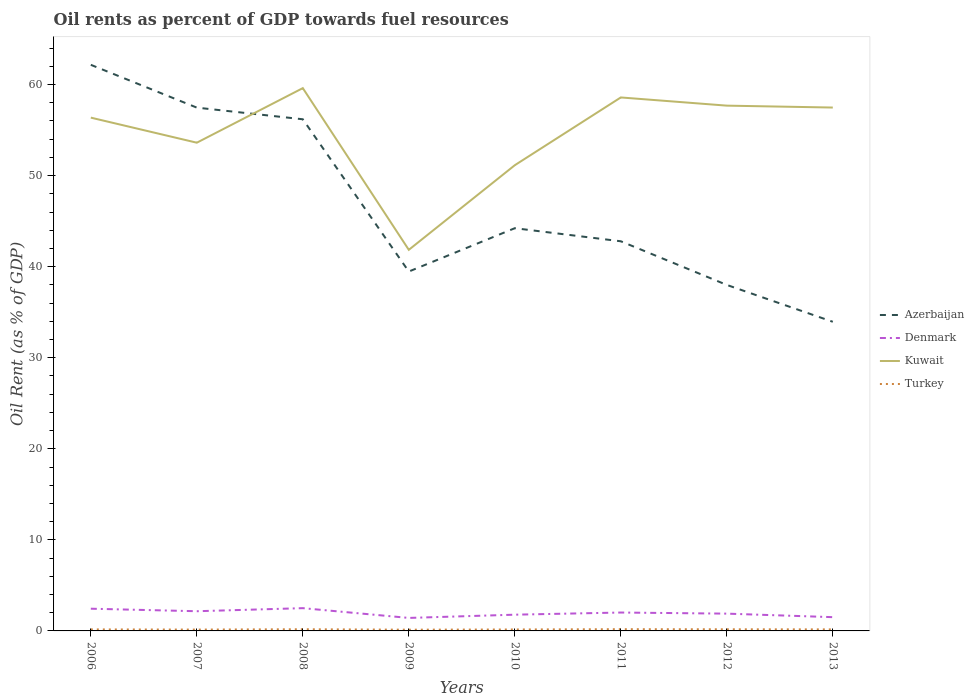Is the number of lines equal to the number of legend labels?
Provide a succinct answer. Yes. Across all years, what is the maximum oil rent in Denmark?
Keep it short and to the point. 1.43. In which year was the oil rent in Turkey maximum?
Offer a terse response. 2009. What is the total oil rent in Kuwait in the graph?
Your response must be concise. -5.99. What is the difference between the highest and the second highest oil rent in Kuwait?
Keep it short and to the point. 17.76. How many lines are there?
Give a very brief answer. 4. Are the values on the major ticks of Y-axis written in scientific E-notation?
Keep it short and to the point. No. What is the title of the graph?
Provide a succinct answer. Oil rents as percent of GDP towards fuel resources. Does "Sierra Leone" appear as one of the legend labels in the graph?
Offer a terse response. No. What is the label or title of the Y-axis?
Offer a terse response. Oil Rent (as % of GDP). What is the Oil Rent (as % of GDP) of Azerbaijan in 2006?
Ensure brevity in your answer.  62.17. What is the Oil Rent (as % of GDP) of Denmark in 2006?
Keep it short and to the point. 2.44. What is the Oil Rent (as % of GDP) of Kuwait in 2006?
Ensure brevity in your answer.  56.37. What is the Oil Rent (as % of GDP) of Turkey in 2006?
Keep it short and to the point. 0.17. What is the Oil Rent (as % of GDP) of Azerbaijan in 2007?
Give a very brief answer. 57.47. What is the Oil Rent (as % of GDP) in Denmark in 2007?
Offer a very short reply. 2.16. What is the Oil Rent (as % of GDP) in Kuwait in 2007?
Keep it short and to the point. 53.61. What is the Oil Rent (as % of GDP) in Turkey in 2007?
Provide a succinct answer. 0.15. What is the Oil Rent (as % of GDP) in Azerbaijan in 2008?
Provide a short and direct response. 56.19. What is the Oil Rent (as % of GDP) of Denmark in 2008?
Make the answer very short. 2.5. What is the Oil Rent (as % of GDP) in Kuwait in 2008?
Keep it short and to the point. 59.61. What is the Oil Rent (as % of GDP) in Turkey in 2008?
Offer a very short reply. 0.18. What is the Oil Rent (as % of GDP) of Azerbaijan in 2009?
Make the answer very short. 39.47. What is the Oil Rent (as % of GDP) of Denmark in 2009?
Your response must be concise. 1.43. What is the Oil Rent (as % of GDP) of Kuwait in 2009?
Ensure brevity in your answer.  41.85. What is the Oil Rent (as % of GDP) of Turkey in 2009?
Your response must be concise. 0.14. What is the Oil Rent (as % of GDP) of Azerbaijan in 2010?
Your answer should be compact. 44.22. What is the Oil Rent (as % of GDP) of Denmark in 2010?
Make the answer very short. 1.78. What is the Oil Rent (as % of GDP) in Kuwait in 2010?
Provide a succinct answer. 51.14. What is the Oil Rent (as % of GDP) of Turkey in 2010?
Make the answer very short. 0.16. What is the Oil Rent (as % of GDP) of Azerbaijan in 2011?
Provide a short and direct response. 42.79. What is the Oil Rent (as % of GDP) in Denmark in 2011?
Ensure brevity in your answer.  2.02. What is the Oil Rent (as % of GDP) of Kuwait in 2011?
Ensure brevity in your answer.  58.58. What is the Oil Rent (as % of GDP) of Turkey in 2011?
Your answer should be compact. 0.19. What is the Oil Rent (as % of GDP) in Azerbaijan in 2012?
Ensure brevity in your answer.  37.99. What is the Oil Rent (as % of GDP) in Denmark in 2012?
Your answer should be very brief. 1.9. What is the Oil Rent (as % of GDP) in Kuwait in 2012?
Your answer should be compact. 57.68. What is the Oil Rent (as % of GDP) of Turkey in 2012?
Your answer should be compact. 0.18. What is the Oil Rent (as % of GDP) in Azerbaijan in 2013?
Your answer should be compact. 33.95. What is the Oil Rent (as % of GDP) in Denmark in 2013?
Your answer should be very brief. 1.51. What is the Oil Rent (as % of GDP) in Kuwait in 2013?
Make the answer very short. 57.47. What is the Oil Rent (as % of GDP) in Turkey in 2013?
Your answer should be very brief. 0.17. Across all years, what is the maximum Oil Rent (as % of GDP) in Azerbaijan?
Offer a terse response. 62.17. Across all years, what is the maximum Oil Rent (as % of GDP) of Denmark?
Offer a terse response. 2.5. Across all years, what is the maximum Oil Rent (as % of GDP) of Kuwait?
Make the answer very short. 59.61. Across all years, what is the maximum Oil Rent (as % of GDP) of Turkey?
Make the answer very short. 0.19. Across all years, what is the minimum Oil Rent (as % of GDP) in Azerbaijan?
Provide a short and direct response. 33.95. Across all years, what is the minimum Oil Rent (as % of GDP) in Denmark?
Make the answer very short. 1.43. Across all years, what is the minimum Oil Rent (as % of GDP) of Kuwait?
Your answer should be very brief. 41.85. Across all years, what is the minimum Oil Rent (as % of GDP) of Turkey?
Give a very brief answer. 0.14. What is the total Oil Rent (as % of GDP) of Azerbaijan in the graph?
Keep it short and to the point. 374.24. What is the total Oil Rent (as % of GDP) of Denmark in the graph?
Provide a succinct answer. 15.74. What is the total Oil Rent (as % of GDP) of Kuwait in the graph?
Give a very brief answer. 436.31. What is the total Oil Rent (as % of GDP) of Turkey in the graph?
Keep it short and to the point. 1.33. What is the difference between the Oil Rent (as % of GDP) in Azerbaijan in 2006 and that in 2007?
Provide a succinct answer. 4.7. What is the difference between the Oil Rent (as % of GDP) in Denmark in 2006 and that in 2007?
Provide a succinct answer. 0.28. What is the difference between the Oil Rent (as % of GDP) in Kuwait in 2006 and that in 2007?
Your answer should be very brief. 2.75. What is the difference between the Oil Rent (as % of GDP) of Turkey in 2006 and that in 2007?
Your answer should be compact. 0.02. What is the difference between the Oil Rent (as % of GDP) in Azerbaijan in 2006 and that in 2008?
Ensure brevity in your answer.  5.98. What is the difference between the Oil Rent (as % of GDP) of Denmark in 2006 and that in 2008?
Your answer should be compact. -0.06. What is the difference between the Oil Rent (as % of GDP) in Kuwait in 2006 and that in 2008?
Provide a short and direct response. -3.24. What is the difference between the Oil Rent (as % of GDP) of Turkey in 2006 and that in 2008?
Keep it short and to the point. -0.02. What is the difference between the Oil Rent (as % of GDP) in Azerbaijan in 2006 and that in 2009?
Your answer should be compact. 22.7. What is the difference between the Oil Rent (as % of GDP) in Denmark in 2006 and that in 2009?
Provide a succinct answer. 1.01. What is the difference between the Oil Rent (as % of GDP) of Kuwait in 2006 and that in 2009?
Make the answer very short. 14.52. What is the difference between the Oil Rent (as % of GDP) of Turkey in 2006 and that in 2009?
Offer a terse response. 0.03. What is the difference between the Oil Rent (as % of GDP) of Azerbaijan in 2006 and that in 2010?
Provide a succinct answer. 17.94. What is the difference between the Oil Rent (as % of GDP) of Denmark in 2006 and that in 2010?
Provide a succinct answer. 0.66. What is the difference between the Oil Rent (as % of GDP) in Kuwait in 2006 and that in 2010?
Offer a very short reply. 5.22. What is the difference between the Oil Rent (as % of GDP) in Turkey in 2006 and that in 2010?
Your response must be concise. 0.01. What is the difference between the Oil Rent (as % of GDP) in Azerbaijan in 2006 and that in 2011?
Keep it short and to the point. 19.38. What is the difference between the Oil Rent (as % of GDP) in Denmark in 2006 and that in 2011?
Provide a succinct answer. 0.42. What is the difference between the Oil Rent (as % of GDP) of Kuwait in 2006 and that in 2011?
Provide a succinct answer. -2.22. What is the difference between the Oil Rent (as % of GDP) of Turkey in 2006 and that in 2011?
Provide a short and direct response. -0.02. What is the difference between the Oil Rent (as % of GDP) of Azerbaijan in 2006 and that in 2012?
Provide a succinct answer. 24.17. What is the difference between the Oil Rent (as % of GDP) of Denmark in 2006 and that in 2012?
Your answer should be compact. 0.54. What is the difference between the Oil Rent (as % of GDP) of Kuwait in 2006 and that in 2012?
Provide a short and direct response. -1.32. What is the difference between the Oil Rent (as % of GDP) of Turkey in 2006 and that in 2012?
Keep it short and to the point. -0.01. What is the difference between the Oil Rent (as % of GDP) in Azerbaijan in 2006 and that in 2013?
Ensure brevity in your answer.  28.22. What is the difference between the Oil Rent (as % of GDP) in Denmark in 2006 and that in 2013?
Offer a very short reply. 0.93. What is the difference between the Oil Rent (as % of GDP) of Kuwait in 2006 and that in 2013?
Your answer should be very brief. -1.11. What is the difference between the Oil Rent (as % of GDP) in Turkey in 2006 and that in 2013?
Keep it short and to the point. -0. What is the difference between the Oil Rent (as % of GDP) of Azerbaijan in 2007 and that in 2008?
Give a very brief answer. 1.28. What is the difference between the Oil Rent (as % of GDP) in Denmark in 2007 and that in 2008?
Offer a terse response. -0.34. What is the difference between the Oil Rent (as % of GDP) of Kuwait in 2007 and that in 2008?
Ensure brevity in your answer.  -5.99. What is the difference between the Oil Rent (as % of GDP) in Turkey in 2007 and that in 2008?
Offer a very short reply. -0.03. What is the difference between the Oil Rent (as % of GDP) of Azerbaijan in 2007 and that in 2009?
Keep it short and to the point. 18. What is the difference between the Oil Rent (as % of GDP) in Denmark in 2007 and that in 2009?
Your answer should be compact. 0.74. What is the difference between the Oil Rent (as % of GDP) of Kuwait in 2007 and that in 2009?
Provide a short and direct response. 11.76. What is the difference between the Oil Rent (as % of GDP) of Turkey in 2007 and that in 2009?
Offer a very short reply. 0.01. What is the difference between the Oil Rent (as % of GDP) in Azerbaijan in 2007 and that in 2010?
Make the answer very short. 13.24. What is the difference between the Oil Rent (as % of GDP) of Denmark in 2007 and that in 2010?
Provide a short and direct response. 0.38. What is the difference between the Oil Rent (as % of GDP) of Kuwait in 2007 and that in 2010?
Your answer should be very brief. 2.47. What is the difference between the Oil Rent (as % of GDP) in Turkey in 2007 and that in 2010?
Make the answer very short. -0.01. What is the difference between the Oil Rent (as % of GDP) of Azerbaijan in 2007 and that in 2011?
Provide a short and direct response. 14.68. What is the difference between the Oil Rent (as % of GDP) of Denmark in 2007 and that in 2011?
Keep it short and to the point. 0.14. What is the difference between the Oil Rent (as % of GDP) of Kuwait in 2007 and that in 2011?
Make the answer very short. -4.97. What is the difference between the Oil Rent (as % of GDP) in Turkey in 2007 and that in 2011?
Keep it short and to the point. -0.04. What is the difference between the Oil Rent (as % of GDP) in Azerbaijan in 2007 and that in 2012?
Make the answer very short. 19.47. What is the difference between the Oil Rent (as % of GDP) in Denmark in 2007 and that in 2012?
Your answer should be very brief. 0.26. What is the difference between the Oil Rent (as % of GDP) of Kuwait in 2007 and that in 2012?
Keep it short and to the point. -4.07. What is the difference between the Oil Rent (as % of GDP) in Turkey in 2007 and that in 2012?
Provide a short and direct response. -0.03. What is the difference between the Oil Rent (as % of GDP) of Azerbaijan in 2007 and that in 2013?
Keep it short and to the point. 23.52. What is the difference between the Oil Rent (as % of GDP) in Denmark in 2007 and that in 2013?
Offer a terse response. 0.65. What is the difference between the Oil Rent (as % of GDP) in Kuwait in 2007 and that in 2013?
Provide a succinct answer. -3.86. What is the difference between the Oil Rent (as % of GDP) of Turkey in 2007 and that in 2013?
Ensure brevity in your answer.  -0.02. What is the difference between the Oil Rent (as % of GDP) in Azerbaijan in 2008 and that in 2009?
Offer a very short reply. 16.72. What is the difference between the Oil Rent (as % of GDP) in Denmark in 2008 and that in 2009?
Your response must be concise. 1.07. What is the difference between the Oil Rent (as % of GDP) of Kuwait in 2008 and that in 2009?
Your answer should be very brief. 17.76. What is the difference between the Oil Rent (as % of GDP) in Turkey in 2008 and that in 2009?
Provide a short and direct response. 0.05. What is the difference between the Oil Rent (as % of GDP) of Azerbaijan in 2008 and that in 2010?
Make the answer very short. 11.96. What is the difference between the Oil Rent (as % of GDP) of Denmark in 2008 and that in 2010?
Offer a terse response. 0.72. What is the difference between the Oil Rent (as % of GDP) of Kuwait in 2008 and that in 2010?
Your answer should be very brief. 8.46. What is the difference between the Oil Rent (as % of GDP) of Turkey in 2008 and that in 2010?
Keep it short and to the point. 0.02. What is the difference between the Oil Rent (as % of GDP) in Azerbaijan in 2008 and that in 2011?
Your answer should be very brief. 13.4. What is the difference between the Oil Rent (as % of GDP) of Denmark in 2008 and that in 2011?
Provide a succinct answer. 0.48. What is the difference between the Oil Rent (as % of GDP) of Kuwait in 2008 and that in 2011?
Give a very brief answer. 1.02. What is the difference between the Oil Rent (as % of GDP) in Turkey in 2008 and that in 2011?
Give a very brief answer. -0.01. What is the difference between the Oil Rent (as % of GDP) in Azerbaijan in 2008 and that in 2012?
Your answer should be compact. 18.19. What is the difference between the Oil Rent (as % of GDP) of Denmark in 2008 and that in 2012?
Provide a short and direct response. 0.6. What is the difference between the Oil Rent (as % of GDP) in Kuwait in 2008 and that in 2012?
Offer a very short reply. 1.92. What is the difference between the Oil Rent (as % of GDP) in Turkey in 2008 and that in 2012?
Keep it short and to the point. 0. What is the difference between the Oil Rent (as % of GDP) of Azerbaijan in 2008 and that in 2013?
Ensure brevity in your answer.  22.24. What is the difference between the Oil Rent (as % of GDP) in Denmark in 2008 and that in 2013?
Offer a terse response. 0.99. What is the difference between the Oil Rent (as % of GDP) of Kuwait in 2008 and that in 2013?
Provide a succinct answer. 2.13. What is the difference between the Oil Rent (as % of GDP) in Turkey in 2008 and that in 2013?
Keep it short and to the point. 0.02. What is the difference between the Oil Rent (as % of GDP) of Azerbaijan in 2009 and that in 2010?
Your answer should be very brief. -4.76. What is the difference between the Oil Rent (as % of GDP) of Denmark in 2009 and that in 2010?
Offer a terse response. -0.36. What is the difference between the Oil Rent (as % of GDP) of Kuwait in 2009 and that in 2010?
Your answer should be compact. -9.29. What is the difference between the Oil Rent (as % of GDP) in Turkey in 2009 and that in 2010?
Your response must be concise. -0.02. What is the difference between the Oil Rent (as % of GDP) in Azerbaijan in 2009 and that in 2011?
Ensure brevity in your answer.  -3.32. What is the difference between the Oil Rent (as % of GDP) of Denmark in 2009 and that in 2011?
Give a very brief answer. -0.59. What is the difference between the Oil Rent (as % of GDP) of Kuwait in 2009 and that in 2011?
Make the answer very short. -16.73. What is the difference between the Oil Rent (as % of GDP) of Turkey in 2009 and that in 2011?
Offer a very short reply. -0.05. What is the difference between the Oil Rent (as % of GDP) in Azerbaijan in 2009 and that in 2012?
Give a very brief answer. 1.47. What is the difference between the Oil Rent (as % of GDP) of Denmark in 2009 and that in 2012?
Your answer should be compact. -0.47. What is the difference between the Oil Rent (as % of GDP) of Kuwait in 2009 and that in 2012?
Your answer should be very brief. -15.83. What is the difference between the Oil Rent (as % of GDP) in Turkey in 2009 and that in 2012?
Provide a succinct answer. -0.04. What is the difference between the Oil Rent (as % of GDP) in Azerbaijan in 2009 and that in 2013?
Offer a very short reply. 5.52. What is the difference between the Oil Rent (as % of GDP) of Denmark in 2009 and that in 2013?
Your response must be concise. -0.08. What is the difference between the Oil Rent (as % of GDP) in Kuwait in 2009 and that in 2013?
Make the answer very short. -15.63. What is the difference between the Oil Rent (as % of GDP) in Turkey in 2009 and that in 2013?
Provide a short and direct response. -0.03. What is the difference between the Oil Rent (as % of GDP) in Azerbaijan in 2010 and that in 2011?
Ensure brevity in your answer.  1.44. What is the difference between the Oil Rent (as % of GDP) in Denmark in 2010 and that in 2011?
Your answer should be compact. -0.24. What is the difference between the Oil Rent (as % of GDP) of Kuwait in 2010 and that in 2011?
Ensure brevity in your answer.  -7.44. What is the difference between the Oil Rent (as % of GDP) of Turkey in 2010 and that in 2011?
Make the answer very short. -0.03. What is the difference between the Oil Rent (as % of GDP) of Azerbaijan in 2010 and that in 2012?
Make the answer very short. 6.23. What is the difference between the Oil Rent (as % of GDP) in Denmark in 2010 and that in 2012?
Ensure brevity in your answer.  -0.11. What is the difference between the Oil Rent (as % of GDP) in Kuwait in 2010 and that in 2012?
Offer a terse response. -6.54. What is the difference between the Oil Rent (as % of GDP) of Turkey in 2010 and that in 2012?
Give a very brief answer. -0.02. What is the difference between the Oil Rent (as % of GDP) in Azerbaijan in 2010 and that in 2013?
Ensure brevity in your answer.  10.28. What is the difference between the Oil Rent (as % of GDP) in Denmark in 2010 and that in 2013?
Keep it short and to the point. 0.27. What is the difference between the Oil Rent (as % of GDP) of Kuwait in 2010 and that in 2013?
Your answer should be compact. -6.33. What is the difference between the Oil Rent (as % of GDP) in Turkey in 2010 and that in 2013?
Make the answer very short. -0.01. What is the difference between the Oil Rent (as % of GDP) in Azerbaijan in 2011 and that in 2012?
Your answer should be compact. 4.79. What is the difference between the Oil Rent (as % of GDP) in Denmark in 2011 and that in 2012?
Your answer should be very brief. 0.12. What is the difference between the Oil Rent (as % of GDP) of Kuwait in 2011 and that in 2012?
Your response must be concise. 0.9. What is the difference between the Oil Rent (as % of GDP) in Turkey in 2011 and that in 2012?
Your answer should be very brief. 0.01. What is the difference between the Oil Rent (as % of GDP) of Azerbaijan in 2011 and that in 2013?
Provide a succinct answer. 8.84. What is the difference between the Oil Rent (as % of GDP) of Denmark in 2011 and that in 2013?
Your answer should be compact. 0.51. What is the difference between the Oil Rent (as % of GDP) in Kuwait in 2011 and that in 2013?
Offer a terse response. 1.11. What is the difference between the Oil Rent (as % of GDP) of Turkey in 2011 and that in 2013?
Your answer should be compact. 0.02. What is the difference between the Oil Rent (as % of GDP) in Azerbaijan in 2012 and that in 2013?
Keep it short and to the point. 4.05. What is the difference between the Oil Rent (as % of GDP) of Denmark in 2012 and that in 2013?
Keep it short and to the point. 0.39. What is the difference between the Oil Rent (as % of GDP) of Kuwait in 2012 and that in 2013?
Ensure brevity in your answer.  0.21. What is the difference between the Oil Rent (as % of GDP) in Turkey in 2012 and that in 2013?
Ensure brevity in your answer.  0.01. What is the difference between the Oil Rent (as % of GDP) in Azerbaijan in 2006 and the Oil Rent (as % of GDP) in Denmark in 2007?
Your answer should be compact. 60. What is the difference between the Oil Rent (as % of GDP) in Azerbaijan in 2006 and the Oil Rent (as % of GDP) in Kuwait in 2007?
Your answer should be compact. 8.55. What is the difference between the Oil Rent (as % of GDP) in Azerbaijan in 2006 and the Oil Rent (as % of GDP) in Turkey in 2007?
Ensure brevity in your answer.  62.02. What is the difference between the Oil Rent (as % of GDP) in Denmark in 2006 and the Oil Rent (as % of GDP) in Kuwait in 2007?
Your response must be concise. -51.17. What is the difference between the Oil Rent (as % of GDP) in Denmark in 2006 and the Oil Rent (as % of GDP) in Turkey in 2007?
Offer a terse response. 2.29. What is the difference between the Oil Rent (as % of GDP) in Kuwait in 2006 and the Oil Rent (as % of GDP) in Turkey in 2007?
Your answer should be very brief. 56.22. What is the difference between the Oil Rent (as % of GDP) in Azerbaijan in 2006 and the Oil Rent (as % of GDP) in Denmark in 2008?
Offer a very short reply. 59.67. What is the difference between the Oil Rent (as % of GDP) in Azerbaijan in 2006 and the Oil Rent (as % of GDP) in Kuwait in 2008?
Your answer should be compact. 2.56. What is the difference between the Oil Rent (as % of GDP) in Azerbaijan in 2006 and the Oil Rent (as % of GDP) in Turkey in 2008?
Your answer should be compact. 61.98. What is the difference between the Oil Rent (as % of GDP) in Denmark in 2006 and the Oil Rent (as % of GDP) in Kuwait in 2008?
Your answer should be very brief. -57.17. What is the difference between the Oil Rent (as % of GDP) in Denmark in 2006 and the Oil Rent (as % of GDP) in Turkey in 2008?
Keep it short and to the point. 2.26. What is the difference between the Oil Rent (as % of GDP) in Kuwait in 2006 and the Oil Rent (as % of GDP) in Turkey in 2008?
Your answer should be compact. 56.18. What is the difference between the Oil Rent (as % of GDP) of Azerbaijan in 2006 and the Oil Rent (as % of GDP) of Denmark in 2009?
Ensure brevity in your answer.  60.74. What is the difference between the Oil Rent (as % of GDP) of Azerbaijan in 2006 and the Oil Rent (as % of GDP) of Kuwait in 2009?
Give a very brief answer. 20.32. What is the difference between the Oil Rent (as % of GDP) in Azerbaijan in 2006 and the Oil Rent (as % of GDP) in Turkey in 2009?
Keep it short and to the point. 62.03. What is the difference between the Oil Rent (as % of GDP) of Denmark in 2006 and the Oil Rent (as % of GDP) of Kuwait in 2009?
Ensure brevity in your answer.  -39.41. What is the difference between the Oil Rent (as % of GDP) in Denmark in 2006 and the Oil Rent (as % of GDP) in Turkey in 2009?
Your response must be concise. 2.3. What is the difference between the Oil Rent (as % of GDP) in Kuwait in 2006 and the Oil Rent (as % of GDP) in Turkey in 2009?
Your response must be concise. 56.23. What is the difference between the Oil Rent (as % of GDP) of Azerbaijan in 2006 and the Oil Rent (as % of GDP) of Denmark in 2010?
Make the answer very short. 60.38. What is the difference between the Oil Rent (as % of GDP) in Azerbaijan in 2006 and the Oil Rent (as % of GDP) in Kuwait in 2010?
Offer a very short reply. 11.02. What is the difference between the Oil Rent (as % of GDP) of Azerbaijan in 2006 and the Oil Rent (as % of GDP) of Turkey in 2010?
Provide a short and direct response. 62.01. What is the difference between the Oil Rent (as % of GDP) in Denmark in 2006 and the Oil Rent (as % of GDP) in Kuwait in 2010?
Your answer should be very brief. -48.7. What is the difference between the Oil Rent (as % of GDP) of Denmark in 2006 and the Oil Rent (as % of GDP) of Turkey in 2010?
Your answer should be very brief. 2.28. What is the difference between the Oil Rent (as % of GDP) in Kuwait in 2006 and the Oil Rent (as % of GDP) in Turkey in 2010?
Your answer should be very brief. 56.21. What is the difference between the Oil Rent (as % of GDP) in Azerbaijan in 2006 and the Oil Rent (as % of GDP) in Denmark in 2011?
Provide a succinct answer. 60.15. What is the difference between the Oil Rent (as % of GDP) in Azerbaijan in 2006 and the Oil Rent (as % of GDP) in Kuwait in 2011?
Give a very brief answer. 3.58. What is the difference between the Oil Rent (as % of GDP) of Azerbaijan in 2006 and the Oil Rent (as % of GDP) of Turkey in 2011?
Provide a short and direct response. 61.98. What is the difference between the Oil Rent (as % of GDP) in Denmark in 2006 and the Oil Rent (as % of GDP) in Kuwait in 2011?
Give a very brief answer. -56.14. What is the difference between the Oil Rent (as % of GDP) in Denmark in 2006 and the Oil Rent (as % of GDP) in Turkey in 2011?
Your response must be concise. 2.25. What is the difference between the Oil Rent (as % of GDP) of Kuwait in 2006 and the Oil Rent (as % of GDP) of Turkey in 2011?
Provide a short and direct response. 56.18. What is the difference between the Oil Rent (as % of GDP) of Azerbaijan in 2006 and the Oil Rent (as % of GDP) of Denmark in 2012?
Offer a very short reply. 60.27. What is the difference between the Oil Rent (as % of GDP) of Azerbaijan in 2006 and the Oil Rent (as % of GDP) of Kuwait in 2012?
Your answer should be very brief. 4.48. What is the difference between the Oil Rent (as % of GDP) in Azerbaijan in 2006 and the Oil Rent (as % of GDP) in Turkey in 2012?
Make the answer very short. 61.99. What is the difference between the Oil Rent (as % of GDP) of Denmark in 2006 and the Oil Rent (as % of GDP) of Kuwait in 2012?
Give a very brief answer. -55.24. What is the difference between the Oil Rent (as % of GDP) in Denmark in 2006 and the Oil Rent (as % of GDP) in Turkey in 2012?
Ensure brevity in your answer.  2.26. What is the difference between the Oil Rent (as % of GDP) in Kuwait in 2006 and the Oil Rent (as % of GDP) in Turkey in 2012?
Your answer should be compact. 56.19. What is the difference between the Oil Rent (as % of GDP) in Azerbaijan in 2006 and the Oil Rent (as % of GDP) in Denmark in 2013?
Provide a short and direct response. 60.65. What is the difference between the Oil Rent (as % of GDP) of Azerbaijan in 2006 and the Oil Rent (as % of GDP) of Kuwait in 2013?
Give a very brief answer. 4.69. What is the difference between the Oil Rent (as % of GDP) of Azerbaijan in 2006 and the Oil Rent (as % of GDP) of Turkey in 2013?
Your response must be concise. 62. What is the difference between the Oil Rent (as % of GDP) of Denmark in 2006 and the Oil Rent (as % of GDP) of Kuwait in 2013?
Your response must be concise. -55.03. What is the difference between the Oil Rent (as % of GDP) in Denmark in 2006 and the Oil Rent (as % of GDP) in Turkey in 2013?
Your answer should be compact. 2.27. What is the difference between the Oil Rent (as % of GDP) of Kuwait in 2006 and the Oil Rent (as % of GDP) of Turkey in 2013?
Your response must be concise. 56.2. What is the difference between the Oil Rent (as % of GDP) of Azerbaijan in 2007 and the Oil Rent (as % of GDP) of Denmark in 2008?
Provide a short and direct response. 54.97. What is the difference between the Oil Rent (as % of GDP) in Azerbaijan in 2007 and the Oil Rent (as % of GDP) in Kuwait in 2008?
Your answer should be compact. -2.14. What is the difference between the Oil Rent (as % of GDP) of Azerbaijan in 2007 and the Oil Rent (as % of GDP) of Turkey in 2008?
Provide a succinct answer. 57.28. What is the difference between the Oil Rent (as % of GDP) in Denmark in 2007 and the Oil Rent (as % of GDP) in Kuwait in 2008?
Your answer should be compact. -57.44. What is the difference between the Oil Rent (as % of GDP) of Denmark in 2007 and the Oil Rent (as % of GDP) of Turkey in 2008?
Provide a short and direct response. 1.98. What is the difference between the Oil Rent (as % of GDP) of Kuwait in 2007 and the Oil Rent (as % of GDP) of Turkey in 2008?
Your response must be concise. 53.43. What is the difference between the Oil Rent (as % of GDP) of Azerbaijan in 2007 and the Oil Rent (as % of GDP) of Denmark in 2009?
Your answer should be very brief. 56.04. What is the difference between the Oil Rent (as % of GDP) of Azerbaijan in 2007 and the Oil Rent (as % of GDP) of Kuwait in 2009?
Provide a short and direct response. 15.62. What is the difference between the Oil Rent (as % of GDP) of Azerbaijan in 2007 and the Oil Rent (as % of GDP) of Turkey in 2009?
Your response must be concise. 57.33. What is the difference between the Oil Rent (as % of GDP) in Denmark in 2007 and the Oil Rent (as % of GDP) in Kuwait in 2009?
Provide a short and direct response. -39.69. What is the difference between the Oil Rent (as % of GDP) of Denmark in 2007 and the Oil Rent (as % of GDP) of Turkey in 2009?
Provide a short and direct response. 2.03. What is the difference between the Oil Rent (as % of GDP) in Kuwait in 2007 and the Oil Rent (as % of GDP) in Turkey in 2009?
Your response must be concise. 53.48. What is the difference between the Oil Rent (as % of GDP) of Azerbaijan in 2007 and the Oil Rent (as % of GDP) of Denmark in 2010?
Your response must be concise. 55.68. What is the difference between the Oil Rent (as % of GDP) in Azerbaijan in 2007 and the Oil Rent (as % of GDP) in Kuwait in 2010?
Offer a terse response. 6.32. What is the difference between the Oil Rent (as % of GDP) of Azerbaijan in 2007 and the Oil Rent (as % of GDP) of Turkey in 2010?
Make the answer very short. 57.31. What is the difference between the Oil Rent (as % of GDP) of Denmark in 2007 and the Oil Rent (as % of GDP) of Kuwait in 2010?
Ensure brevity in your answer.  -48.98. What is the difference between the Oil Rent (as % of GDP) of Denmark in 2007 and the Oil Rent (as % of GDP) of Turkey in 2010?
Your response must be concise. 2. What is the difference between the Oil Rent (as % of GDP) of Kuwait in 2007 and the Oil Rent (as % of GDP) of Turkey in 2010?
Your answer should be very brief. 53.46. What is the difference between the Oil Rent (as % of GDP) of Azerbaijan in 2007 and the Oil Rent (as % of GDP) of Denmark in 2011?
Offer a very short reply. 55.45. What is the difference between the Oil Rent (as % of GDP) of Azerbaijan in 2007 and the Oil Rent (as % of GDP) of Kuwait in 2011?
Provide a short and direct response. -1.12. What is the difference between the Oil Rent (as % of GDP) in Azerbaijan in 2007 and the Oil Rent (as % of GDP) in Turkey in 2011?
Your answer should be very brief. 57.28. What is the difference between the Oil Rent (as % of GDP) in Denmark in 2007 and the Oil Rent (as % of GDP) in Kuwait in 2011?
Your answer should be compact. -56.42. What is the difference between the Oil Rent (as % of GDP) of Denmark in 2007 and the Oil Rent (as % of GDP) of Turkey in 2011?
Offer a very short reply. 1.97. What is the difference between the Oil Rent (as % of GDP) in Kuwait in 2007 and the Oil Rent (as % of GDP) in Turkey in 2011?
Your answer should be very brief. 53.42. What is the difference between the Oil Rent (as % of GDP) in Azerbaijan in 2007 and the Oil Rent (as % of GDP) in Denmark in 2012?
Your answer should be very brief. 55.57. What is the difference between the Oil Rent (as % of GDP) of Azerbaijan in 2007 and the Oil Rent (as % of GDP) of Kuwait in 2012?
Your answer should be very brief. -0.22. What is the difference between the Oil Rent (as % of GDP) of Azerbaijan in 2007 and the Oil Rent (as % of GDP) of Turkey in 2012?
Your answer should be compact. 57.29. What is the difference between the Oil Rent (as % of GDP) in Denmark in 2007 and the Oil Rent (as % of GDP) in Kuwait in 2012?
Your response must be concise. -55.52. What is the difference between the Oil Rent (as % of GDP) of Denmark in 2007 and the Oil Rent (as % of GDP) of Turkey in 2012?
Make the answer very short. 1.98. What is the difference between the Oil Rent (as % of GDP) of Kuwait in 2007 and the Oil Rent (as % of GDP) of Turkey in 2012?
Make the answer very short. 53.43. What is the difference between the Oil Rent (as % of GDP) of Azerbaijan in 2007 and the Oil Rent (as % of GDP) of Denmark in 2013?
Offer a very short reply. 55.95. What is the difference between the Oil Rent (as % of GDP) of Azerbaijan in 2007 and the Oil Rent (as % of GDP) of Kuwait in 2013?
Offer a very short reply. -0.01. What is the difference between the Oil Rent (as % of GDP) of Azerbaijan in 2007 and the Oil Rent (as % of GDP) of Turkey in 2013?
Keep it short and to the point. 57.3. What is the difference between the Oil Rent (as % of GDP) of Denmark in 2007 and the Oil Rent (as % of GDP) of Kuwait in 2013?
Ensure brevity in your answer.  -55.31. What is the difference between the Oil Rent (as % of GDP) in Denmark in 2007 and the Oil Rent (as % of GDP) in Turkey in 2013?
Your answer should be compact. 2. What is the difference between the Oil Rent (as % of GDP) in Kuwait in 2007 and the Oil Rent (as % of GDP) in Turkey in 2013?
Keep it short and to the point. 53.45. What is the difference between the Oil Rent (as % of GDP) in Azerbaijan in 2008 and the Oil Rent (as % of GDP) in Denmark in 2009?
Provide a succinct answer. 54.76. What is the difference between the Oil Rent (as % of GDP) of Azerbaijan in 2008 and the Oil Rent (as % of GDP) of Kuwait in 2009?
Make the answer very short. 14.34. What is the difference between the Oil Rent (as % of GDP) in Azerbaijan in 2008 and the Oil Rent (as % of GDP) in Turkey in 2009?
Offer a terse response. 56.05. What is the difference between the Oil Rent (as % of GDP) in Denmark in 2008 and the Oil Rent (as % of GDP) in Kuwait in 2009?
Make the answer very short. -39.35. What is the difference between the Oil Rent (as % of GDP) in Denmark in 2008 and the Oil Rent (as % of GDP) in Turkey in 2009?
Give a very brief answer. 2.36. What is the difference between the Oil Rent (as % of GDP) in Kuwait in 2008 and the Oil Rent (as % of GDP) in Turkey in 2009?
Keep it short and to the point. 59.47. What is the difference between the Oil Rent (as % of GDP) of Azerbaijan in 2008 and the Oil Rent (as % of GDP) of Denmark in 2010?
Make the answer very short. 54.4. What is the difference between the Oil Rent (as % of GDP) of Azerbaijan in 2008 and the Oil Rent (as % of GDP) of Kuwait in 2010?
Provide a short and direct response. 5.04. What is the difference between the Oil Rent (as % of GDP) of Azerbaijan in 2008 and the Oil Rent (as % of GDP) of Turkey in 2010?
Keep it short and to the point. 56.03. What is the difference between the Oil Rent (as % of GDP) of Denmark in 2008 and the Oil Rent (as % of GDP) of Kuwait in 2010?
Keep it short and to the point. -48.64. What is the difference between the Oil Rent (as % of GDP) in Denmark in 2008 and the Oil Rent (as % of GDP) in Turkey in 2010?
Provide a short and direct response. 2.34. What is the difference between the Oil Rent (as % of GDP) in Kuwait in 2008 and the Oil Rent (as % of GDP) in Turkey in 2010?
Ensure brevity in your answer.  59.45. What is the difference between the Oil Rent (as % of GDP) in Azerbaijan in 2008 and the Oil Rent (as % of GDP) in Denmark in 2011?
Your answer should be compact. 54.17. What is the difference between the Oil Rent (as % of GDP) of Azerbaijan in 2008 and the Oil Rent (as % of GDP) of Kuwait in 2011?
Provide a short and direct response. -2.4. What is the difference between the Oil Rent (as % of GDP) of Azerbaijan in 2008 and the Oil Rent (as % of GDP) of Turkey in 2011?
Provide a short and direct response. 56. What is the difference between the Oil Rent (as % of GDP) of Denmark in 2008 and the Oil Rent (as % of GDP) of Kuwait in 2011?
Ensure brevity in your answer.  -56.08. What is the difference between the Oil Rent (as % of GDP) of Denmark in 2008 and the Oil Rent (as % of GDP) of Turkey in 2011?
Make the answer very short. 2.31. What is the difference between the Oil Rent (as % of GDP) of Kuwait in 2008 and the Oil Rent (as % of GDP) of Turkey in 2011?
Your answer should be very brief. 59.42. What is the difference between the Oil Rent (as % of GDP) of Azerbaijan in 2008 and the Oil Rent (as % of GDP) of Denmark in 2012?
Offer a terse response. 54.29. What is the difference between the Oil Rent (as % of GDP) in Azerbaijan in 2008 and the Oil Rent (as % of GDP) in Kuwait in 2012?
Offer a very short reply. -1.5. What is the difference between the Oil Rent (as % of GDP) in Azerbaijan in 2008 and the Oil Rent (as % of GDP) in Turkey in 2012?
Your answer should be very brief. 56.01. What is the difference between the Oil Rent (as % of GDP) in Denmark in 2008 and the Oil Rent (as % of GDP) in Kuwait in 2012?
Offer a terse response. -55.18. What is the difference between the Oil Rent (as % of GDP) of Denmark in 2008 and the Oil Rent (as % of GDP) of Turkey in 2012?
Your response must be concise. 2.32. What is the difference between the Oil Rent (as % of GDP) in Kuwait in 2008 and the Oil Rent (as % of GDP) in Turkey in 2012?
Provide a short and direct response. 59.43. What is the difference between the Oil Rent (as % of GDP) in Azerbaijan in 2008 and the Oil Rent (as % of GDP) in Denmark in 2013?
Make the answer very short. 54.67. What is the difference between the Oil Rent (as % of GDP) in Azerbaijan in 2008 and the Oil Rent (as % of GDP) in Kuwait in 2013?
Your answer should be compact. -1.29. What is the difference between the Oil Rent (as % of GDP) of Azerbaijan in 2008 and the Oil Rent (as % of GDP) of Turkey in 2013?
Your response must be concise. 56.02. What is the difference between the Oil Rent (as % of GDP) of Denmark in 2008 and the Oil Rent (as % of GDP) of Kuwait in 2013?
Offer a terse response. -54.97. What is the difference between the Oil Rent (as % of GDP) of Denmark in 2008 and the Oil Rent (as % of GDP) of Turkey in 2013?
Provide a short and direct response. 2.33. What is the difference between the Oil Rent (as % of GDP) in Kuwait in 2008 and the Oil Rent (as % of GDP) in Turkey in 2013?
Give a very brief answer. 59.44. What is the difference between the Oil Rent (as % of GDP) in Azerbaijan in 2009 and the Oil Rent (as % of GDP) in Denmark in 2010?
Offer a terse response. 37.68. What is the difference between the Oil Rent (as % of GDP) of Azerbaijan in 2009 and the Oil Rent (as % of GDP) of Kuwait in 2010?
Provide a short and direct response. -11.68. What is the difference between the Oil Rent (as % of GDP) in Azerbaijan in 2009 and the Oil Rent (as % of GDP) in Turkey in 2010?
Your answer should be compact. 39.31. What is the difference between the Oil Rent (as % of GDP) of Denmark in 2009 and the Oil Rent (as % of GDP) of Kuwait in 2010?
Offer a terse response. -49.71. What is the difference between the Oil Rent (as % of GDP) in Denmark in 2009 and the Oil Rent (as % of GDP) in Turkey in 2010?
Your response must be concise. 1.27. What is the difference between the Oil Rent (as % of GDP) in Kuwait in 2009 and the Oil Rent (as % of GDP) in Turkey in 2010?
Your answer should be compact. 41.69. What is the difference between the Oil Rent (as % of GDP) in Azerbaijan in 2009 and the Oil Rent (as % of GDP) in Denmark in 2011?
Keep it short and to the point. 37.45. What is the difference between the Oil Rent (as % of GDP) in Azerbaijan in 2009 and the Oil Rent (as % of GDP) in Kuwait in 2011?
Make the answer very short. -19.12. What is the difference between the Oil Rent (as % of GDP) of Azerbaijan in 2009 and the Oil Rent (as % of GDP) of Turkey in 2011?
Give a very brief answer. 39.28. What is the difference between the Oil Rent (as % of GDP) of Denmark in 2009 and the Oil Rent (as % of GDP) of Kuwait in 2011?
Ensure brevity in your answer.  -57.16. What is the difference between the Oil Rent (as % of GDP) of Denmark in 2009 and the Oil Rent (as % of GDP) of Turkey in 2011?
Keep it short and to the point. 1.24. What is the difference between the Oil Rent (as % of GDP) in Kuwait in 2009 and the Oil Rent (as % of GDP) in Turkey in 2011?
Your answer should be compact. 41.66. What is the difference between the Oil Rent (as % of GDP) in Azerbaijan in 2009 and the Oil Rent (as % of GDP) in Denmark in 2012?
Make the answer very short. 37.57. What is the difference between the Oil Rent (as % of GDP) in Azerbaijan in 2009 and the Oil Rent (as % of GDP) in Kuwait in 2012?
Give a very brief answer. -18.22. What is the difference between the Oil Rent (as % of GDP) of Azerbaijan in 2009 and the Oil Rent (as % of GDP) of Turkey in 2012?
Ensure brevity in your answer.  39.29. What is the difference between the Oil Rent (as % of GDP) of Denmark in 2009 and the Oil Rent (as % of GDP) of Kuwait in 2012?
Your response must be concise. -56.26. What is the difference between the Oil Rent (as % of GDP) in Denmark in 2009 and the Oil Rent (as % of GDP) in Turkey in 2012?
Keep it short and to the point. 1.25. What is the difference between the Oil Rent (as % of GDP) in Kuwait in 2009 and the Oil Rent (as % of GDP) in Turkey in 2012?
Offer a terse response. 41.67. What is the difference between the Oil Rent (as % of GDP) in Azerbaijan in 2009 and the Oil Rent (as % of GDP) in Denmark in 2013?
Make the answer very short. 37.95. What is the difference between the Oil Rent (as % of GDP) in Azerbaijan in 2009 and the Oil Rent (as % of GDP) in Kuwait in 2013?
Your response must be concise. -18.01. What is the difference between the Oil Rent (as % of GDP) in Azerbaijan in 2009 and the Oil Rent (as % of GDP) in Turkey in 2013?
Give a very brief answer. 39.3. What is the difference between the Oil Rent (as % of GDP) of Denmark in 2009 and the Oil Rent (as % of GDP) of Kuwait in 2013?
Your answer should be very brief. -56.05. What is the difference between the Oil Rent (as % of GDP) in Denmark in 2009 and the Oil Rent (as % of GDP) in Turkey in 2013?
Your answer should be very brief. 1.26. What is the difference between the Oil Rent (as % of GDP) of Kuwait in 2009 and the Oil Rent (as % of GDP) of Turkey in 2013?
Offer a terse response. 41.68. What is the difference between the Oil Rent (as % of GDP) in Azerbaijan in 2010 and the Oil Rent (as % of GDP) in Denmark in 2011?
Offer a terse response. 42.2. What is the difference between the Oil Rent (as % of GDP) of Azerbaijan in 2010 and the Oil Rent (as % of GDP) of Kuwait in 2011?
Your answer should be very brief. -14.36. What is the difference between the Oil Rent (as % of GDP) of Azerbaijan in 2010 and the Oil Rent (as % of GDP) of Turkey in 2011?
Ensure brevity in your answer.  44.03. What is the difference between the Oil Rent (as % of GDP) of Denmark in 2010 and the Oil Rent (as % of GDP) of Kuwait in 2011?
Give a very brief answer. -56.8. What is the difference between the Oil Rent (as % of GDP) of Denmark in 2010 and the Oil Rent (as % of GDP) of Turkey in 2011?
Keep it short and to the point. 1.59. What is the difference between the Oil Rent (as % of GDP) in Kuwait in 2010 and the Oil Rent (as % of GDP) in Turkey in 2011?
Provide a succinct answer. 50.95. What is the difference between the Oil Rent (as % of GDP) in Azerbaijan in 2010 and the Oil Rent (as % of GDP) in Denmark in 2012?
Provide a short and direct response. 42.33. What is the difference between the Oil Rent (as % of GDP) of Azerbaijan in 2010 and the Oil Rent (as % of GDP) of Kuwait in 2012?
Provide a short and direct response. -13.46. What is the difference between the Oil Rent (as % of GDP) of Azerbaijan in 2010 and the Oil Rent (as % of GDP) of Turkey in 2012?
Make the answer very short. 44.05. What is the difference between the Oil Rent (as % of GDP) in Denmark in 2010 and the Oil Rent (as % of GDP) in Kuwait in 2012?
Offer a terse response. -55.9. What is the difference between the Oil Rent (as % of GDP) of Denmark in 2010 and the Oil Rent (as % of GDP) of Turkey in 2012?
Your response must be concise. 1.6. What is the difference between the Oil Rent (as % of GDP) of Kuwait in 2010 and the Oil Rent (as % of GDP) of Turkey in 2012?
Give a very brief answer. 50.96. What is the difference between the Oil Rent (as % of GDP) of Azerbaijan in 2010 and the Oil Rent (as % of GDP) of Denmark in 2013?
Make the answer very short. 42.71. What is the difference between the Oil Rent (as % of GDP) of Azerbaijan in 2010 and the Oil Rent (as % of GDP) of Kuwait in 2013?
Ensure brevity in your answer.  -13.25. What is the difference between the Oil Rent (as % of GDP) in Azerbaijan in 2010 and the Oil Rent (as % of GDP) in Turkey in 2013?
Offer a terse response. 44.06. What is the difference between the Oil Rent (as % of GDP) in Denmark in 2010 and the Oil Rent (as % of GDP) in Kuwait in 2013?
Provide a succinct answer. -55.69. What is the difference between the Oil Rent (as % of GDP) of Denmark in 2010 and the Oil Rent (as % of GDP) of Turkey in 2013?
Your response must be concise. 1.62. What is the difference between the Oil Rent (as % of GDP) in Kuwait in 2010 and the Oil Rent (as % of GDP) in Turkey in 2013?
Give a very brief answer. 50.97. What is the difference between the Oil Rent (as % of GDP) in Azerbaijan in 2011 and the Oil Rent (as % of GDP) in Denmark in 2012?
Keep it short and to the point. 40.89. What is the difference between the Oil Rent (as % of GDP) in Azerbaijan in 2011 and the Oil Rent (as % of GDP) in Kuwait in 2012?
Provide a short and direct response. -14.89. What is the difference between the Oil Rent (as % of GDP) in Azerbaijan in 2011 and the Oil Rent (as % of GDP) in Turkey in 2012?
Offer a terse response. 42.61. What is the difference between the Oil Rent (as % of GDP) of Denmark in 2011 and the Oil Rent (as % of GDP) of Kuwait in 2012?
Give a very brief answer. -55.66. What is the difference between the Oil Rent (as % of GDP) in Denmark in 2011 and the Oil Rent (as % of GDP) in Turkey in 2012?
Ensure brevity in your answer.  1.84. What is the difference between the Oil Rent (as % of GDP) in Kuwait in 2011 and the Oil Rent (as % of GDP) in Turkey in 2012?
Provide a succinct answer. 58.4. What is the difference between the Oil Rent (as % of GDP) of Azerbaijan in 2011 and the Oil Rent (as % of GDP) of Denmark in 2013?
Provide a short and direct response. 41.28. What is the difference between the Oil Rent (as % of GDP) in Azerbaijan in 2011 and the Oil Rent (as % of GDP) in Kuwait in 2013?
Provide a succinct answer. -14.69. What is the difference between the Oil Rent (as % of GDP) in Azerbaijan in 2011 and the Oil Rent (as % of GDP) in Turkey in 2013?
Keep it short and to the point. 42.62. What is the difference between the Oil Rent (as % of GDP) in Denmark in 2011 and the Oil Rent (as % of GDP) in Kuwait in 2013?
Your answer should be very brief. -55.45. What is the difference between the Oil Rent (as % of GDP) in Denmark in 2011 and the Oil Rent (as % of GDP) in Turkey in 2013?
Give a very brief answer. 1.85. What is the difference between the Oil Rent (as % of GDP) of Kuwait in 2011 and the Oil Rent (as % of GDP) of Turkey in 2013?
Provide a succinct answer. 58.42. What is the difference between the Oil Rent (as % of GDP) in Azerbaijan in 2012 and the Oil Rent (as % of GDP) in Denmark in 2013?
Offer a terse response. 36.48. What is the difference between the Oil Rent (as % of GDP) in Azerbaijan in 2012 and the Oil Rent (as % of GDP) in Kuwait in 2013?
Offer a very short reply. -19.48. What is the difference between the Oil Rent (as % of GDP) in Azerbaijan in 2012 and the Oil Rent (as % of GDP) in Turkey in 2013?
Your answer should be very brief. 37.83. What is the difference between the Oil Rent (as % of GDP) in Denmark in 2012 and the Oil Rent (as % of GDP) in Kuwait in 2013?
Give a very brief answer. -55.58. What is the difference between the Oil Rent (as % of GDP) of Denmark in 2012 and the Oil Rent (as % of GDP) of Turkey in 2013?
Your answer should be compact. 1.73. What is the difference between the Oil Rent (as % of GDP) of Kuwait in 2012 and the Oil Rent (as % of GDP) of Turkey in 2013?
Keep it short and to the point. 57.51. What is the average Oil Rent (as % of GDP) in Azerbaijan per year?
Offer a very short reply. 46.78. What is the average Oil Rent (as % of GDP) in Denmark per year?
Give a very brief answer. 1.97. What is the average Oil Rent (as % of GDP) in Kuwait per year?
Offer a very short reply. 54.54. What is the average Oil Rent (as % of GDP) in Turkey per year?
Your answer should be very brief. 0.17. In the year 2006, what is the difference between the Oil Rent (as % of GDP) in Azerbaijan and Oil Rent (as % of GDP) in Denmark?
Provide a succinct answer. 59.73. In the year 2006, what is the difference between the Oil Rent (as % of GDP) in Azerbaijan and Oil Rent (as % of GDP) in Kuwait?
Offer a terse response. 5.8. In the year 2006, what is the difference between the Oil Rent (as % of GDP) in Azerbaijan and Oil Rent (as % of GDP) in Turkey?
Your answer should be very brief. 62. In the year 2006, what is the difference between the Oil Rent (as % of GDP) in Denmark and Oil Rent (as % of GDP) in Kuwait?
Your response must be concise. -53.93. In the year 2006, what is the difference between the Oil Rent (as % of GDP) of Denmark and Oil Rent (as % of GDP) of Turkey?
Your answer should be compact. 2.27. In the year 2006, what is the difference between the Oil Rent (as % of GDP) in Kuwait and Oil Rent (as % of GDP) in Turkey?
Your response must be concise. 56.2. In the year 2007, what is the difference between the Oil Rent (as % of GDP) of Azerbaijan and Oil Rent (as % of GDP) of Denmark?
Provide a succinct answer. 55.3. In the year 2007, what is the difference between the Oil Rent (as % of GDP) in Azerbaijan and Oil Rent (as % of GDP) in Kuwait?
Your answer should be compact. 3.85. In the year 2007, what is the difference between the Oil Rent (as % of GDP) in Azerbaijan and Oil Rent (as % of GDP) in Turkey?
Make the answer very short. 57.32. In the year 2007, what is the difference between the Oil Rent (as % of GDP) in Denmark and Oil Rent (as % of GDP) in Kuwait?
Provide a succinct answer. -51.45. In the year 2007, what is the difference between the Oil Rent (as % of GDP) of Denmark and Oil Rent (as % of GDP) of Turkey?
Give a very brief answer. 2.01. In the year 2007, what is the difference between the Oil Rent (as % of GDP) in Kuwait and Oil Rent (as % of GDP) in Turkey?
Offer a terse response. 53.47. In the year 2008, what is the difference between the Oil Rent (as % of GDP) of Azerbaijan and Oil Rent (as % of GDP) of Denmark?
Offer a terse response. 53.69. In the year 2008, what is the difference between the Oil Rent (as % of GDP) of Azerbaijan and Oil Rent (as % of GDP) of Kuwait?
Your response must be concise. -3.42. In the year 2008, what is the difference between the Oil Rent (as % of GDP) of Azerbaijan and Oil Rent (as % of GDP) of Turkey?
Your response must be concise. 56. In the year 2008, what is the difference between the Oil Rent (as % of GDP) in Denmark and Oil Rent (as % of GDP) in Kuwait?
Your answer should be compact. -57.11. In the year 2008, what is the difference between the Oil Rent (as % of GDP) of Denmark and Oil Rent (as % of GDP) of Turkey?
Keep it short and to the point. 2.32. In the year 2008, what is the difference between the Oil Rent (as % of GDP) of Kuwait and Oil Rent (as % of GDP) of Turkey?
Give a very brief answer. 59.42. In the year 2009, what is the difference between the Oil Rent (as % of GDP) in Azerbaijan and Oil Rent (as % of GDP) in Denmark?
Provide a short and direct response. 38.04. In the year 2009, what is the difference between the Oil Rent (as % of GDP) in Azerbaijan and Oil Rent (as % of GDP) in Kuwait?
Offer a terse response. -2.38. In the year 2009, what is the difference between the Oil Rent (as % of GDP) of Azerbaijan and Oil Rent (as % of GDP) of Turkey?
Your answer should be compact. 39.33. In the year 2009, what is the difference between the Oil Rent (as % of GDP) of Denmark and Oil Rent (as % of GDP) of Kuwait?
Provide a short and direct response. -40.42. In the year 2009, what is the difference between the Oil Rent (as % of GDP) of Denmark and Oil Rent (as % of GDP) of Turkey?
Your response must be concise. 1.29. In the year 2009, what is the difference between the Oil Rent (as % of GDP) in Kuwait and Oil Rent (as % of GDP) in Turkey?
Provide a short and direct response. 41.71. In the year 2010, what is the difference between the Oil Rent (as % of GDP) of Azerbaijan and Oil Rent (as % of GDP) of Denmark?
Keep it short and to the point. 42.44. In the year 2010, what is the difference between the Oil Rent (as % of GDP) of Azerbaijan and Oil Rent (as % of GDP) of Kuwait?
Provide a short and direct response. -6.92. In the year 2010, what is the difference between the Oil Rent (as % of GDP) in Azerbaijan and Oil Rent (as % of GDP) in Turkey?
Ensure brevity in your answer.  44.07. In the year 2010, what is the difference between the Oil Rent (as % of GDP) in Denmark and Oil Rent (as % of GDP) in Kuwait?
Give a very brief answer. -49.36. In the year 2010, what is the difference between the Oil Rent (as % of GDP) of Denmark and Oil Rent (as % of GDP) of Turkey?
Keep it short and to the point. 1.63. In the year 2010, what is the difference between the Oil Rent (as % of GDP) of Kuwait and Oil Rent (as % of GDP) of Turkey?
Your response must be concise. 50.98. In the year 2011, what is the difference between the Oil Rent (as % of GDP) in Azerbaijan and Oil Rent (as % of GDP) in Denmark?
Ensure brevity in your answer.  40.77. In the year 2011, what is the difference between the Oil Rent (as % of GDP) of Azerbaijan and Oil Rent (as % of GDP) of Kuwait?
Give a very brief answer. -15.8. In the year 2011, what is the difference between the Oil Rent (as % of GDP) in Azerbaijan and Oil Rent (as % of GDP) in Turkey?
Make the answer very short. 42.6. In the year 2011, what is the difference between the Oil Rent (as % of GDP) of Denmark and Oil Rent (as % of GDP) of Kuwait?
Offer a very short reply. -56.56. In the year 2011, what is the difference between the Oil Rent (as % of GDP) in Denmark and Oil Rent (as % of GDP) in Turkey?
Your answer should be very brief. 1.83. In the year 2011, what is the difference between the Oil Rent (as % of GDP) of Kuwait and Oil Rent (as % of GDP) of Turkey?
Your answer should be compact. 58.39. In the year 2012, what is the difference between the Oil Rent (as % of GDP) in Azerbaijan and Oil Rent (as % of GDP) in Denmark?
Your answer should be very brief. 36.1. In the year 2012, what is the difference between the Oil Rent (as % of GDP) of Azerbaijan and Oil Rent (as % of GDP) of Kuwait?
Your answer should be very brief. -19.69. In the year 2012, what is the difference between the Oil Rent (as % of GDP) in Azerbaijan and Oil Rent (as % of GDP) in Turkey?
Provide a short and direct response. 37.82. In the year 2012, what is the difference between the Oil Rent (as % of GDP) in Denmark and Oil Rent (as % of GDP) in Kuwait?
Offer a very short reply. -55.78. In the year 2012, what is the difference between the Oil Rent (as % of GDP) of Denmark and Oil Rent (as % of GDP) of Turkey?
Give a very brief answer. 1.72. In the year 2012, what is the difference between the Oil Rent (as % of GDP) in Kuwait and Oil Rent (as % of GDP) in Turkey?
Give a very brief answer. 57.5. In the year 2013, what is the difference between the Oil Rent (as % of GDP) in Azerbaijan and Oil Rent (as % of GDP) in Denmark?
Provide a short and direct response. 32.44. In the year 2013, what is the difference between the Oil Rent (as % of GDP) of Azerbaijan and Oil Rent (as % of GDP) of Kuwait?
Ensure brevity in your answer.  -23.53. In the year 2013, what is the difference between the Oil Rent (as % of GDP) in Azerbaijan and Oil Rent (as % of GDP) in Turkey?
Provide a succinct answer. 33.78. In the year 2013, what is the difference between the Oil Rent (as % of GDP) in Denmark and Oil Rent (as % of GDP) in Kuwait?
Your answer should be compact. -55.96. In the year 2013, what is the difference between the Oil Rent (as % of GDP) of Denmark and Oil Rent (as % of GDP) of Turkey?
Offer a terse response. 1.34. In the year 2013, what is the difference between the Oil Rent (as % of GDP) in Kuwait and Oil Rent (as % of GDP) in Turkey?
Offer a very short reply. 57.31. What is the ratio of the Oil Rent (as % of GDP) of Azerbaijan in 2006 to that in 2007?
Keep it short and to the point. 1.08. What is the ratio of the Oil Rent (as % of GDP) in Denmark in 2006 to that in 2007?
Your response must be concise. 1.13. What is the ratio of the Oil Rent (as % of GDP) in Kuwait in 2006 to that in 2007?
Your response must be concise. 1.05. What is the ratio of the Oil Rent (as % of GDP) of Turkey in 2006 to that in 2007?
Keep it short and to the point. 1.12. What is the ratio of the Oil Rent (as % of GDP) of Azerbaijan in 2006 to that in 2008?
Your answer should be compact. 1.11. What is the ratio of the Oil Rent (as % of GDP) of Denmark in 2006 to that in 2008?
Offer a terse response. 0.98. What is the ratio of the Oil Rent (as % of GDP) of Kuwait in 2006 to that in 2008?
Make the answer very short. 0.95. What is the ratio of the Oil Rent (as % of GDP) in Turkey in 2006 to that in 2008?
Offer a very short reply. 0.91. What is the ratio of the Oil Rent (as % of GDP) of Azerbaijan in 2006 to that in 2009?
Ensure brevity in your answer.  1.58. What is the ratio of the Oil Rent (as % of GDP) in Denmark in 2006 to that in 2009?
Make the answer very short. 1.71. What is the ratio of the Oil Rent (as % of GDP) of Kuwait in 2006 to that in 2009?
Give a very brief answer. 1.35. What is the ratio of the Oil Rent (as % of GDP) in Turkey in 2006 to that in 2009?
Your response must be concise. 1.22. What is the ratio of the Oil Rent (as % of GDP) of Azerbaijan in 2006 to that in 2010?
Your answer should be compact. 1.41. What is the ratio of the Oil Rent (as % of GDP) of Denmark in 2006 to that in 2010?
Your response must be concise. 1.37. What is the ratio of the Oil Rent (as % of GDP) in Kuwait in 2006 to that in 2010?
Offer a very short reply. 1.1. What is the ratio of the Oil Rent (as % of GDP) in Turkey in 2006 to that in 2010?
Your answer should be compact. 1.05. What is the ratio of the Oil Rent (as % of GDP) in Azerbaijan in 2006 to that in 2011?
Provide a short and direct response. 1.45. What is the ratio of the Oil Rent (as % of GDP) in Denmark in 2006 to that in 2011?
Ensure brevity in your answer.  1.21. What is the ratio of the Oil Rent (as % of GDP) in Kuwait in 2006 to that in 2011?
Provide a succinct answer. 0.96. What is the ratio of the Oil Rent (as % of GDP) of Turkey in 2006 to that in 2011?
Your answer should be compact. 0.87. What is the ratio of the Oil Rent (as % of GDP) in Azerbaijan in 2006 to that in 2012?
Offer a terse response. 1.64. What is the ratio of the Oil Rent (as % of GDP) in Denmark in 2006 to that in 2012?
Offer a very short reply. 1.29. What is the ratio of the Oil Rent (as % of GDP) of Kuwait in 2006 to that in 2012?
Provide a short and direct response. 0.98. What is the ratio of the Oil Rent (as % of GDP) of Turkey in 2006 to that in 2012?
Your answer should be compact. 0.93. What is the ratio of the Oil Rent (as % of GDP) of Azerbaijan in 2006 to that in 2013?
Your response must be concise. 1.83. What is the ratio of the Oil Rent (as % of GDP) of Denmark in 2006 to that in 2013?
Offer a terse response. 1.61. What is the ratio of the Oil Rent (as % of GDP) in Kuwait in 2006 to that in 2013?
Ensure brevity in your answer.  0.98. What is the ratio of the Oil Rent (as % of GDP) in Turkey in 2006 to that in 2013?
Keep it short and to the point. 0.99. What is the ratio of the Oil Rent (as % of GDP) in Azerbaijan in 2007 to that in 2008?
Ensure brevity in your answer.  1.02. What is the ratio of the Oil Rent (as % of GDP) in Denmark in 2007 to that in 2008?
Provide a short and direct response. 0.87. What is the ratio of the Oil Rent (as % of GDP) in Kuwait in 2007 to that in 2008?
Provide a succinct answer. 0.9. What is the ratio of the Oil Rent (as % of GDP) in Turkey in 2007 to that in 2008?
Provide a short and direct response. 0.81. What is the ratio of the Oil Rent (as % of GDP) of Azerbaijan in 2007 to that in 2009?
Your answer should be compact. 1.46. What is the ratio of the Oil Rent (as % of GDP) of Denmark in 2007 to that in 2009?
Ensure brevity in your answer.  1.52. What is the ratio of the Oil Rent (as % of GDP) in Kuwait in 2007 to that in 2009?
Provide a succinct answer. 1.28. What is the ratio of the Oil Rent (as % of GDP) of Turkey in 2007 to that in 2009?
Give a very brief answer. 1.09. What is the ratio of the Oil Rent (as % of GDP) of Azerbaijan in 2007 to that in 2010?
Your answer should be compact. 1.3. What is the ratio of the Oil Rent (as % of GDP) of Denmark in 2007 to that in 2010?
Your answer should be compact. 1.21. What is the ratio of the Oil Rent (as % of GDP) in Kuwait in 2007 to that in 2010?
Provide a succinct answer. 1.05. What is the ratio of the Oil Rent (as % of GDP) in Turkey in 2007 to that in 2010?
Give a very brief answer. 0.93. What is the ratio of the Oil Rent (as % of GDP) in Azerbaijan in 2007 to that in 2011?
Offer a terse response. 1.34. What is the ratio of the Oil Rent (as % of GDP) of Denmark in 2007 to that in 2011?
Your answer should be compact. 1.07. What is the ratio of the Oil Rent (as % of GDP) in Kuwait in 2007 to that in 2011?
Provide a short and direct response. 0.92. What is the ratio of the Oil Rent (as % of GDP) in Turkey in 2007 to that in 2011?
Provide a succinct answer. 0.78. What is the ratio of the Oil Rent (as % of GDP) in Azerbaijan in 2007 to that in 2012?
Offer a terse response. 1.51. What is the ratio of the Oil Rent (as % of GDP) in Denmark in 2007 to that in 2012?
Keep it short and to the point. 1.14. What is the ratio of the Oil Rent (as % of GDP) of Kuwait in 2007 to that in 2012?
Provide a succinct answer. 0.93. What is the ratio of the Oil Rent (as % of GDP) in Turkey in 2007 to that in 2012?
Ensure brevity in your answer.  0.83. What is the ratio of the Oil Rent (as % of GDP) in Azerbaijan in 2007 to that in 2013?
Provide a succinct answer. 1.69. What is the ratio of the Oil Rent (as % of GDP) in Denmark in 2007 to that in 2013?
Provide a short and direct response. 1.43. What is the ratio of the Oil Rent (as % of GDP) in Kuwait in 2007 to that in 2013?
Provide a short and direct response. 0.93. What is the ratio of the Oil Rent (as % of GDP) in Turkey in 2007 to that in 2013?
Make the answer very short. 0.88. What is the ratio of the Oil Rent (as % of GDP) of Azerbaijan in 2008 to that in 2009?
Keep it short and to the point. 1.42. What is the ratio of the Oil Rent (as % of GDP) of Denmark in 2008 to that in 2009?
Your answer should be very brief. 1.75. What is the ratio of the Oil Rent (as % of GDP) in Kuwait in 2008 to that in 2009?
Make the answer very short. 1.42. What is the ratio of the Oil Rent (as % of GDP) in Turkey in 2008 to that in 2009?
Give a very brief answer. 1.34. What is the ratio of the Oil Rent (as % of GDP) in Azerbaijan in 2008 to that in 2010?
Offer a very short reply. 1.27. What is the ratio of the Oil Rent (as % of GDP) in Denmark in 2008 to that in 2010?
Make the answer very short. 1.4. What is the ratio of the Oil Rent (as % of GDP) of Kuwait in 2008 to that in 2010?
Keep it short and to the point. 1.17. What is the ratio of the Oil Rent (as % of GDP) of Turkey in 2008 to that in 2010?
Keep it short and to the point. 1.15. What is the ratio of the Oil Rent (as % of GDP) of Azerbaijan in 2008 to that in 2011?
Provide a short and direct response. 1.31. What is the ratio of the Oil Rent (as % of GDP) in Denmark in 2008 to that in 2011?
Ensure brevity in your answer.  1.24. What is the ratio of the Oil Rent (as % of GDP) in Kuwait in 2008 to that in 2011?
Offer a very short reply. 1.02. What is the ratio of the Oil Rent (as % of GDP) in Turkey in 2008 to that in 2011?
Ensure brevity in your answer.  0.96. What is the ratio of the Oil Rent (as % of GDP) of Azerbaijan in 2008 to that in 2012?
Your answer should be compact. 1.48. What is the ratio of the Oil Rent (as % of GDP) in Denmark in 2008 to that in 2012?
Ensure brevity in your answer.  1.32. What is the ratio of the Oil Rent (as % of GDP) in Kuwait in 2008 to that in 2012?
Your response must be concise. 1.03. What is the ratio of the Oil Rent (as % of GDP) in Turkey in 2008 to that in 2012?
Your answer should be compact. 1.02. What is the ratio of the Oil Rent (as % of GDP) in Azerbaijan in 2008 to that in 2013?
Keep it short and to the point. 1.66. What is the ratio of the Oil Rent (as % of GDP) of Denmark in 2008 to that in 2013?
Keep it short and to the point. 1.65. What is the ratio of the Oil Rent (as % of GDP) in Kuwait in 2008 to that in 2013?
Give a very brief answer. 1.04. What is the ratio of the Oil Rent (as % of GDP) in Turkey in 2008 to that in 2013?
Make the answer very short. 1.09. What is the ratio of the Oil Rent (as % of GDP) in Azerbaijan in 2009 to that in 2010?
Make the answer very short. 0.89. What is the ratio of the Oil Rent (as % of GDP) of Denmark in 2009 to that in 2010?
Provide a succinct answer. 0.8. What is the ratio of the Oil Rent (as % of GDP) of Kuwait in 2009 to that in 2010?
Your response must be concise. 0.82. What is the ratio of the Oil Rent (as % of GDP) in Turkey in 2009 to that in 2010?
Your answer should be compact. 0.86. What is the ratio of the Oil Rent (as % of GDP) of Azerbaijan in 2009 to that in 2011?
Give a very brief answer. 0.92. What is the ratio of the Oil Rent (as % of GDP) of Denmark in 2009 to that in 2011?
Your answer should be very brief. 0.71. What is the ratio of the Oil Rent (as % of GDP) of Kuwait in 2009 to that in 2011?
Ensure brevity in your answer.  0.71. What is the ratio of the Oil Rent (as % of GDP) of Turkey in 2009 to that in 2011?
Make the answer very short. 0.72. What is the ratio of the Oil Rent (as % of GDP) in Azerbaijan in 2009 to that in 2012?
Keep it short and to the point. 1.04. What is the ratio of the Oil Rent (as % of GDP) of Denmark in 2009 to that in 2012?
Make the answer very short. 0.75. What is the ratio of the Oil Rent (as % of GDP) in Kuwait in 2009 to that in 2012?
Offer a very short reply. 0.73. What is the ratio of the Oil Rent (as % of GDP) in Turkey in 2009 to that in 2012?
Your answer should be compact. 0.76. What is the ratio of the Oil Rent (as % of GDP) in Azerbaijan in 2009 to that in 2013?
Offer a terse response. 1.16. What is the ratio of the Oil Rent (as % of GDP) in Denmark in 2009 to that in 2013?
Make the answer very short. 0.94. What is the ratio of the Oil Rent (as % of GDP) in Kuwait in 2009 to that in 2013?
Ensure brevity in your answer.  0.73. What is the ratio of the Oil Rent (as % of GDP) of Turkey in 2009 to that in 2013?
Your answer should be compact. 0.81. What is the ratio of the Oil Rent (as % of GDP) in Azerbaijan in 2010 to that in 2011?
Offer a very short reply. 1.03. What is the ratio of the Oil Rent (as % of GDP) in Denmark in 2010 to that in 2011?
Your answer should be compact. 0.88. What is the ratio of the Oil Rent (as % of GDP) of Kuwait in 2010 to that in 2011?
Provide a succinct answer. 0.87. What is the ratio of the Oil Rent (as % of GDP) of Turkey in 2010 to that in 2011?
Your answer should be very brief. 0.83. What is the ratio of the Oil Rent (as % of GDP) in Azerbaijan in 2010 to that in 2012?
Give a very brief answer. 1.16. What is the ratio of the Oil Rent (as % of GDP) of Denmark in 2010 to that in 2012?
Your answer should be very brief. 0.94. What is the ratio of the Oil Rent (as % of GDP) of Kuwait in 2010 to that in 2012?
Ensure brevity in your answer.  0.89. What is the ratio of the Oil Rent (as % of GDP) in Turkey in 2010 to that in 2012?
Provide a short and direct response. 0.89. What is the ratio of the Oil Rent (as % of GDP) of Azerbaijan in 2010 to that in 2013?
Ensure brevity in your answer.  1.3. What is the ratio of the Oil Rent (as % of GDP) in Denmark in 2010 to that in 2013?
Make the answer very short. 1.18. What is the ratio of the Oil Rent (as % of GDP) of Kuwait in 2010 to that in 2013?
Your answer should be very brief. 0.89. What is the ratio of the Oil Rent (as % of GDP) in Turkey in 2010 to that in 2013?
Offer a very short reply. 0.94. What is the ratio of the Oil Rent (as % of GDP) in Azerbaijan in 2011 to that in 2012?
Give a very brief answer. 1.13. What is the ratio of the Oil Rent (as % of GDP) of Denmark in 2011 to that in 2012?
Your answer should be very brief. 1.06. What is the ratio of the Oil Rent (as % of GDP) in Kuwait in 2011 to that in 2012?
Give a very brief answer. 1.02. What is the ratio of the Oil Rent (as % of GDP) of Turkey in 2011 to that in 2012?
Make the answer very short. 1.06. What is the ratio of the Oil Rent (as % of GDP) of Azerbaijan in 2011 to that in 2013?
Keep it short and to the point. 1.26. What is the ratio of the Oil Rent (as % of GDP) of Denmark in 2011 to that in 2013?
Provide a succinct answer. 1.34. What is the ratio of the Oil Rent (as % of GDP) in Kuwait in 2011 to that in 2013?
Give a very brief answer. 1.02. What is the ratio of the Oil Rent (as % of GDP) of Turkey in 2011 to that in 2013?
Make the answer very short. 1.13. What is the ratio of the Oil Rent (as % of GDP) in Azerbaijan in 2012 to that in 2013?
Provide a short and direct response. 1.12. What is the ratio of the Oil Rent (as % of GDP) in Denmark in 2012 to that in 2013?
Your answer should be very brief. 1.26. What is the ratio of the Oil Rent (as % of GDP) in Kuwait in 2012 to that in 2013?
Your response must be concise. 1. What is the ratio of the Oil Rent (as % of GDP) in Turkey in 2012 to that in 2013?
Provide a short and direct response. 1.07. What is the difference between the highest and the second highest Oil Rent (as % of GDP) in Azerbaijan?
Provide a succinct answer. 4.7. What is the difference between the highest and the second highest Oil Rent (as % of GDP) in Denmark?
Offer a very short reply. 0.06. What is the difference between the highest and the second highest Oil Rent (as % of GDP) of Kuwait?
Your answer should be very brief. 1.02. What is the difference between the highest and the second highest Oil Rent (as % of GDP) of Turkey?
Offer a very short reply. 0.01. What is the difference between the highest and the lowest Oil Rent (as % of GDP) in Azerbaijan?
Offer a terse response. 28.22. What is the difference between the highest and the lowest Oil Rent (as % of GDP) of Denmark?
Give a very brief answer. 1.07. What is the difference between the highest and the lowest Oil Rent (as % of GDP) in Kuwait?
Your response must be concise. 17.76. What is the difference between the highest and the lowest Oil Rent (as % of GDP) in Turkey?
Offer a terse response. 0.05. 